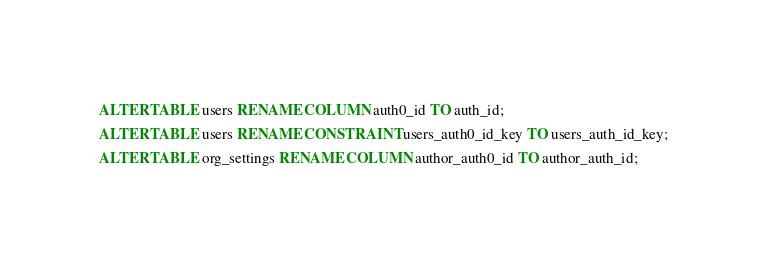<code> <loc_0><loc_0><loc_500><loc_500><_SQL_>ALTER TABLE users RENAME COLUMN auth0_id TO auth_id;
ALTER TABLE users RENAME CONSTRAINT users_auth0_id_key TO users_auth_id_key;
ALTER TABLE org_settings RENAME COLUMN author_auth0_id TO author_auth_id;
</code> 